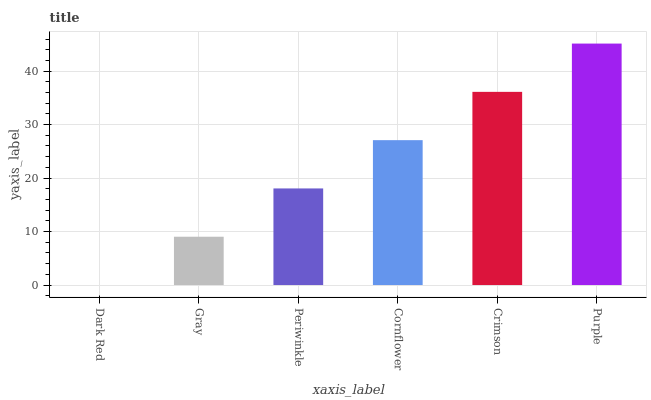Is Gray the minimum?
Answer yes or no. No. Is Gray the maximum?
Answer yes or no. No. Is Gray greater than Dark Red?
Answer yes or no. Yes. Is Dark Red less than Gray?
Answer yes or no. Yes. Is Dark Red greater than Gray?
Answer yes or no. No. Is Gray less than Dark Red?
Answer yes or no. No. Is Cornflower the high median?
Answer yes or no. Yes. Is Periwinkle the low median?
Answer yes or no. Yes. Is Dark Red the high median?
Answer yes or no. No. Is Purple the low median?
Answer yes or no. No. 